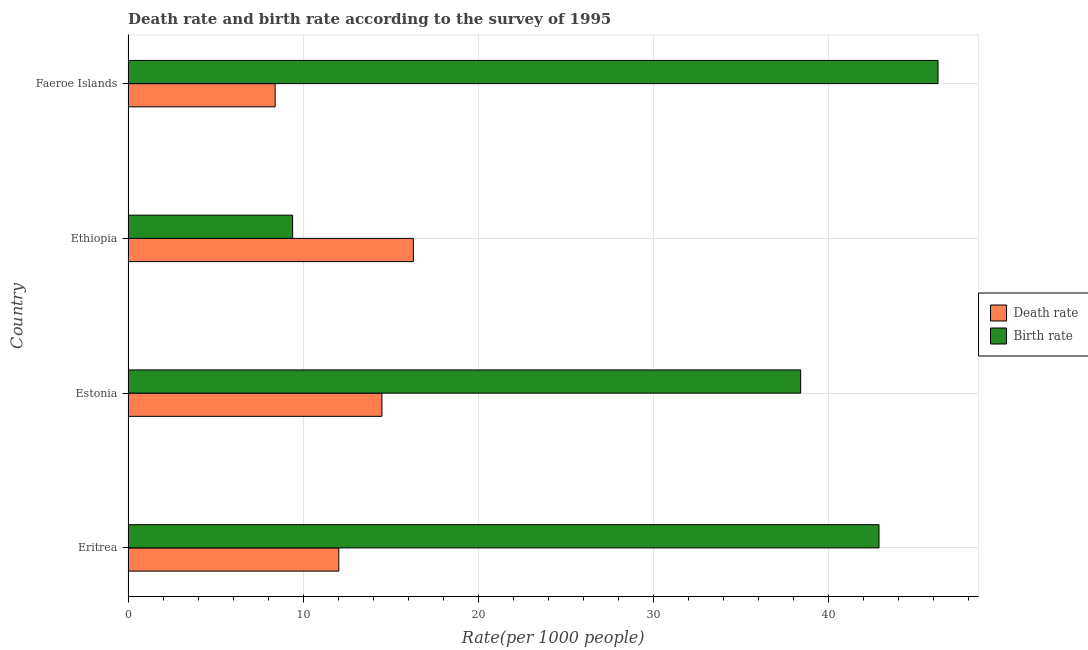How many bars are there on the 3rd tick from the top?
Make the answer very short. 2. How many bars are there on the 2nd tick from the bottom?
Offer a very short reply. 2. What is the label of the 4th group of bars from the top?
Give a very brief answer. Eritrea. What is the birth rate in Eritrea?
Ensure brevity in your answer.  42.89. Across all countries, what is the maximum birth rate?
Make the answer very short. 46.26. In which country was the death rate maximum?
Keep it short and to the point. Ethiopia. In which country was the birth rate minimum?
Make the answer very short. Ethiopia. What is the total death rate in the graph?
Keep it short and to the point. 51.23. What is the difference between the death rate in Eritrea and that in Ethiopia?
Give a very brief answer. -4.26. What is the average death rate per country?
Give a very brief answer. 12.81. What is the difference between the death rate and birth rate in Estonia?
Your response must be concise. -23.92. What is the ratio of the birth rate in Estonia to that in Faeroe Islands?
Ensure brevity in your answer.  0.83. Is the birth rate in Eritrea less than that in Estonia?
Provide a succinct answer. No. Is the difference between the birth rate in Estonia and Ethiopia greater than the difference between the death rate in Estonia and Ethiopia?
Provide a succinct answer. Yes. What is the difference between the highest and the second highest birth rate?
Your answer should be compact. 3.37. What is the difference between the highest and the lowest birth rate?
Offer a terse response. 36.86. Is the sum of the birth rate in Eritrea and Faeroe Islands greater than the maximum death rate across all countries?
Ensure brevity in your answer.  Yes. What does the 1st bar from the top in Eritrea represents?
Provide a succinct answer. Birth rate. What does the 1st bar from the bottom in Eritrea represents?
Make the answer very short. Death rate. How many bars are there?
Provide a succinct answer. 8. How many countries are there in the graph?
Provide a succinct answer. 4. What is the difference between two consecutive major ticks on the X-axis?
Your answer should be compact. 10. Are the values on the major ticks of X-axis written in scientific E-notation?
Make the answer very short. No. Does the graph contain any zero values?
Give a very brief answer. No. Does the graph contain grids?
Give a very brief answer. Yes. How many legend labels are there?
Ensure brevity in your answer.  2. How are the legend labels stacked?
Offer a very short reply. Vertical. What is the title of the graph?
Provide a short and direct response. Death rate and birth rate according to the survey of 1995. Does "GDP at market prices" appear as one of the legend labels in the graph?
Keep it short and to the point. No. What is the label or title of the X-axis?
Offer a terse response. Rate(per 1000 people). What is the label or title of the Y-axis?
Your response must be concise. Country. What is the Rate(per 1000 people) of Death rate in Eritrea?
Your answer should be compact. 12.04. What is the Rate(per 1000 people) of Birth rate in Eritrea?
Offer a very short reply. 42.89. What is the Rate(per 1000 people) of Death rate in Estonia?
Provide a short and direct response. 14.5. What is the Rate(per 1000 people) of Birth rate in Estonia?
Provide a succinct answer. 38.42. What is the Rate(per 1000 people) of Death rate in Ethiopia?
Offer a terse response. 16.3. What is the Rate(per 1000 people) in Birth rate in Ethiopia?
Offer a terse response. 9.4. What is the Rate(per 1000 people) of Birth rate in Faeroe Islands?
Your answer should be compact. 46.26. Across all countries, what is the maximum Rate(per 1000 people) in Death rate?
Provide a short and direct response. 16.3. Across all countries, what is the maximum Rate(per 1000 people) in Birth rate?
Make the answer very short. 46.26. Across all countries, what is the minimum Rate(per 1000 people) of Death rate?
Offer a terse response. 8.4. What is the total Rate(per 1000 people) in Death rate in the graph?
Offer a terse response. 51.23. What is the total Rate(per 1000 people) of Birth rate in the graph?
Keep it short and to the point. 136.97. What is the difference between the Rate(per 1000 people) in Death rate in Eritrea and that in Estonia?
Give a very brief answer. -2.46. What is the difference between the Rate(per 1000 people) of Birth rate in Eritrea and that in Estonia?
Your answer should be very brief. 4.47. What is the difference between the Rate(per 1000 people) of Death rate in Eritrea and that in Ethiopia?
Offer a very short reply. -4.26. What is the difference between the Rate(per 1000 people) of Birth rate in Eritrea and that in Ethiopia?
Keep it short and to the point. 33.49. What is the difference between the Rate(per 1000 people) of Death rate in Eritrea and that in Faeroe Islands?
Your answer should be very brief. 3.64. What is the difference between the Rate(per 1000 people) in Birth rate in Eritrea and that in Faeroe Islands?
Give a very brief answer. -3.37. What is the difference between the Rate(per 1000 people) of Death rate in Estonia and that in Ethiopia?
Make the answer very short. -1.79. What is the difference between the Rate(per 1000 people) in Birth rate in Estonia and that in Ethiopia?
Your response must be concise. 29.02. What is the difference between the Rate(per 1000 people) of Death rate in Estonia and that in Faeroe Islands?
Make the answer very short. 6.1. What is the difference between the Rate(per 1000 people) of Birth rate in Estonia and that in Faeroe Islands?
Offer a very short reply. -7.84. What is the difference between the Rate(per 1000 people) of Death rate in Ethiopia and that in Faeroe Islands?
Offer a very short reply. 7.89. What is the difference between the Rate(per 1000 people) in Birth rate in Ethiopia and that in Faeroe Islands?
Ensure brevity in your answer.  -36.86. What is the difference between the Rate(per 1000 people) in Death rate in Eritrea and the Rate(per 1000 people) in Birth rate in Estonia?
Make the answer very short. -26.38. What is the difference between the Rate(per 1000 people) in Death rate in Eritrea and the Rate(per 1000 people) in Birth rate in Ethiopia?
Your answer should be compact. 2.64. What is the difference between the Rate(per 1000 people) in Death rate in Eritrea and the Rate(per 1000 people) in Birth rate in Faeroe Islands?
Your answer should be very brief. -34.23. What is the difference between the Rate(per 1000 people) in Death rate in Estonia and the Rate(per 1000 people) in Birth rate in Faeroe Islands?
Your response must be concise. -31.76. What is the difference between the Rate(per 1000 people) in Death rate in Ethiopia and the Rate(per 1000 people) in Birth rate in Faeroe Islands?
Offer a terse response. -29.97. What is the average Rate(per 1000 people) in Death rate per country?
Your answer should be very brief. 12.81. What is the average Rate(per 1000 people) in Birth rate per country?
Provide a succinct answer. 34.24. What is the difference between the Rate(per 1000 people) of Death rate and Rate(per 1000 people) of Birth rate in Eritrea?
Provide a succinct answer. -30.86. What is the difference between the Rate(per 1000 people) of Death rate and Rate(per 1000 people) of Birth rate in Estonia?
Your answer should be very brief. -23.92. What is the difference between the Rate(per 1000 people) of Death rate and Rate(per 1000 people) of Birth rate in Ethiopia?
Give a very brief answer. 6.89. What is the difference between the Rate(per 1000 people) in Death rate and Rate(per 1000 people) in Birth rate in Faeroe Islands?
Offer a very short reply. -37.86. What is the ratio of the Rate(per 1000 people) of Death rate in Eritrea to that in Estonia?
Provide a short and direct response. 0.83. What is the ratio of the Rate(per 1000 people) of Birth rate in Eritrea to that in Estonia?
Your answer should be very brief. 1.12. What is the ratio of the Rate(per 1000 people) in Death rate in Eritrea to that in Ethiopia?
Your response must be concise. 0.74. What is the ratio of the Rate(per 1000 people) in Birth rate in Eritrea to that in Ethiopia?
Give a very brief answer. 4.56. What is the ratio of the Rate(per 1000 people) of Death rate in Eritrea to that in Faeroe Islands?
Your answer should be very brief. 1.43. What is the ratio of the Rate(per 1000 people) in Birth rate in Eritrea to that in Faeroe Islands?
Ensure brevity in your answer.  0.93. What is the ratio of the Rate(per 1000 people) in Death rate in Estonia to that in Ethiopia?
Give a very brief answer. 0.89. What is the ratio of the Rate(per 1000 people) in Birth rate in Estonia to that in Ethiopia?
Offer a very short reply. 4.09. What is the ratio of the Rate(per 1000 people) of Death rate in Estonia to that in Faeroe Islands?
Offer a terse response. 1.73. What is the ratio of the Rate(per 1000 people) in Birth rate in Estonia to that in Faeroe Islands?
Your answer should be very brief. 0.83. What is the ratio of the Rate(per 1000 people) in Death rate in Ethiopia to that in Faeroe Islands?
Your answer should be compact. 1.94. What is the ratio of the Rate(per 1000 people) in Birth rate in Ethiopia to that in Faeroe Islands?
Your answer should be very brief. 0.2. What is the difference between the highest and the second highest Rate(per 1000 people) in Death rate?
Provide a short and direct response. 1.79. What is the difference between the highest and the second highest Rate(per 1000 people) in Birth rate?
Offer a terse response. 3.37. What is the difference between the highest and the lowest Rate(per 1000 people) of Death rate?
Your answer should be compact. 7.89. What is the difference between the highest and the lowest Rate(per 1000 people) of Birth rate?
Your answer should be very brief. 36.86. 